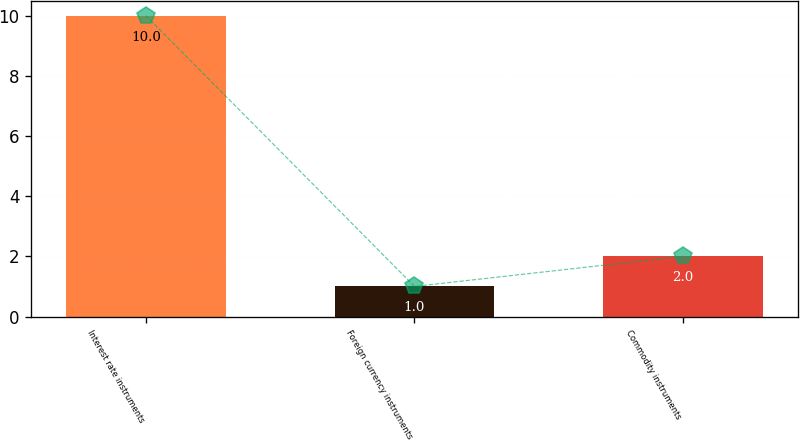Convert chart. <chart><loc_0><loc_0><loc_500><loc_500><bar_chart><fcel>Interest rate instruments<fcel>Foreign currency instruments<fcel>Commodity instruments<nl><fcel>10<fcel>1<fcel>2<nl></chart> 